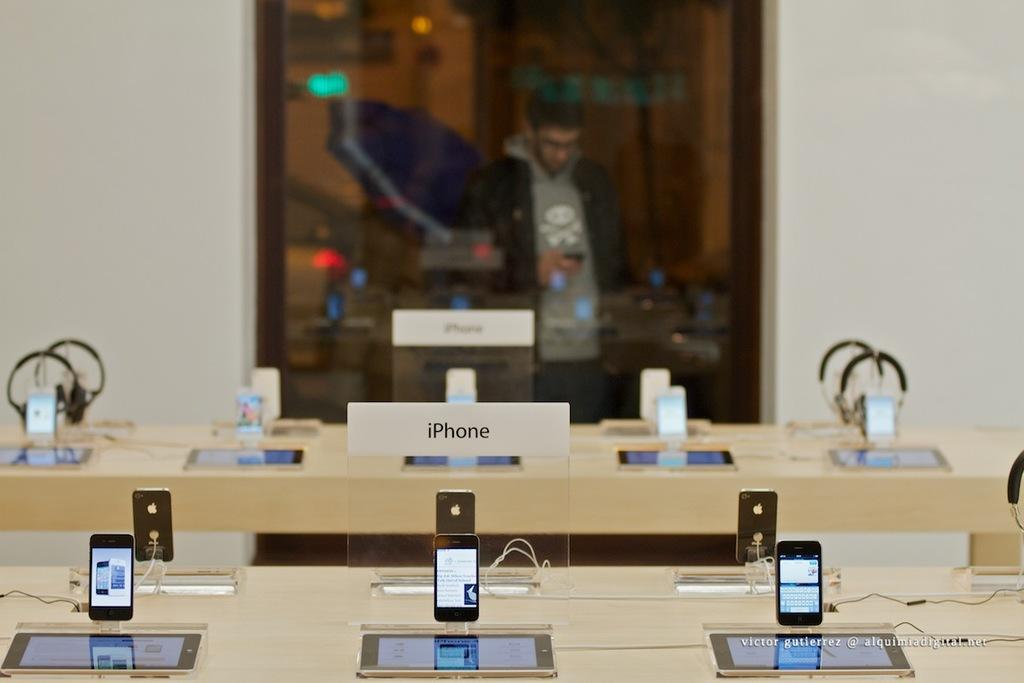Provide a one-sentence caption for the provided image. Victor Gutierrez captured a picture of an Iphone Display inside an Apple store. 